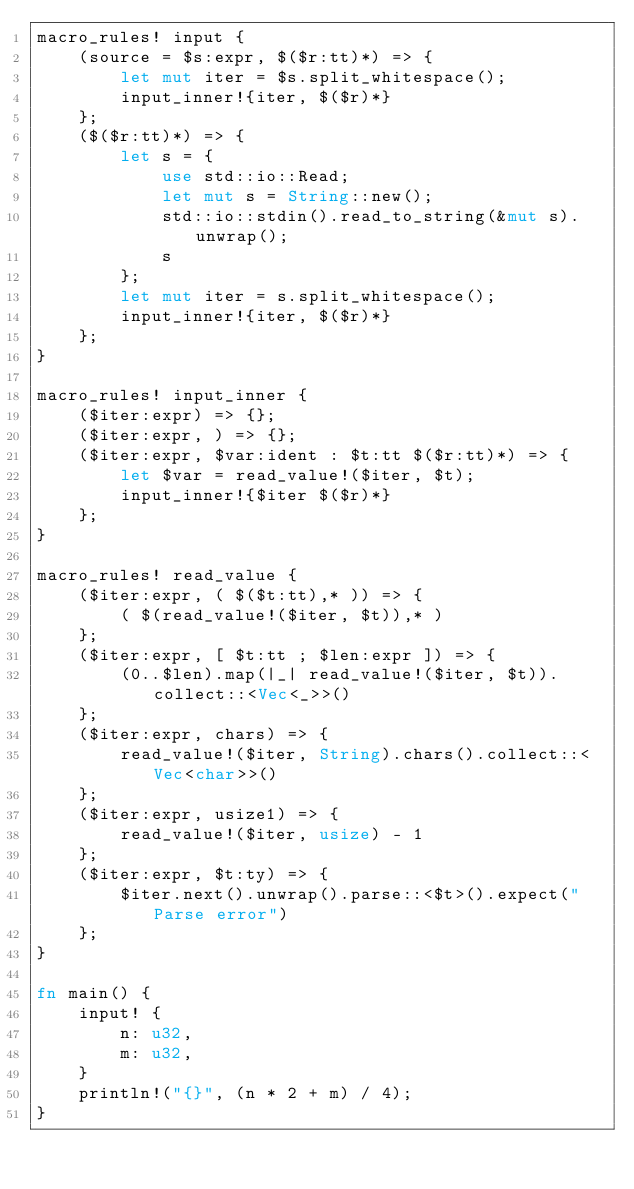Convert code to text. <code><loc_0><loc_0><loc_500><loc_500><_Rust_>macro_rules! input {
    (source = $s:expr, $($r:tt)*) => {
        let mut iter = $s.split_whitespace();
        input_inner!{iter, $($r)*}
    };
    ($($r:tt)*) => {
        let s = {
            use std::io::Read;
            let mut s = String::new();
            std::io::stdin().read_to_string(&mut s).unwrap();
            s
        };
        let mut iter = s.split_whitespace();
        input_inner!{iter, $($r)*}
    };
}

macro_rules! input_inner {
    ($iter:expr) => {};
    ($iter:expr, ) => {};
    ($iter:expr, $var:ident : $t:tt $($r:tt)*) => {
        let $var = read_value!($iter, $t);
        input_inner!{$iter $($r)*}
    };
}

macro_rules! read_value {
    ($iter:expr, ( $($t:tt),* )) => {
        ( $(read_value!($iter, $t)),* )
    };
    ($iter:expr, [ $t:tt ; $len:expr ]) => {
        (0..$len).map(|_| read_value!($iter, $t)).collect::<Vec<_>>()
    };
    ($iter:expr, chars) => {
        read_value!($iter, String).chars().collect::<Vec<char>>()
    };
    ($iter:expr, usize1) => {
        read_value!($iter, usize) - 1
    };
    ($iter:expr, $t:ty) => {
        $iter.next().unwrap().parse::<$t>().expect("Parse error")
    };
}

fn main() {
    input! {
        n: u32,
        m: u32,
    }
    println!("{}", (n * 2 + m) / 4);
}
</code> 